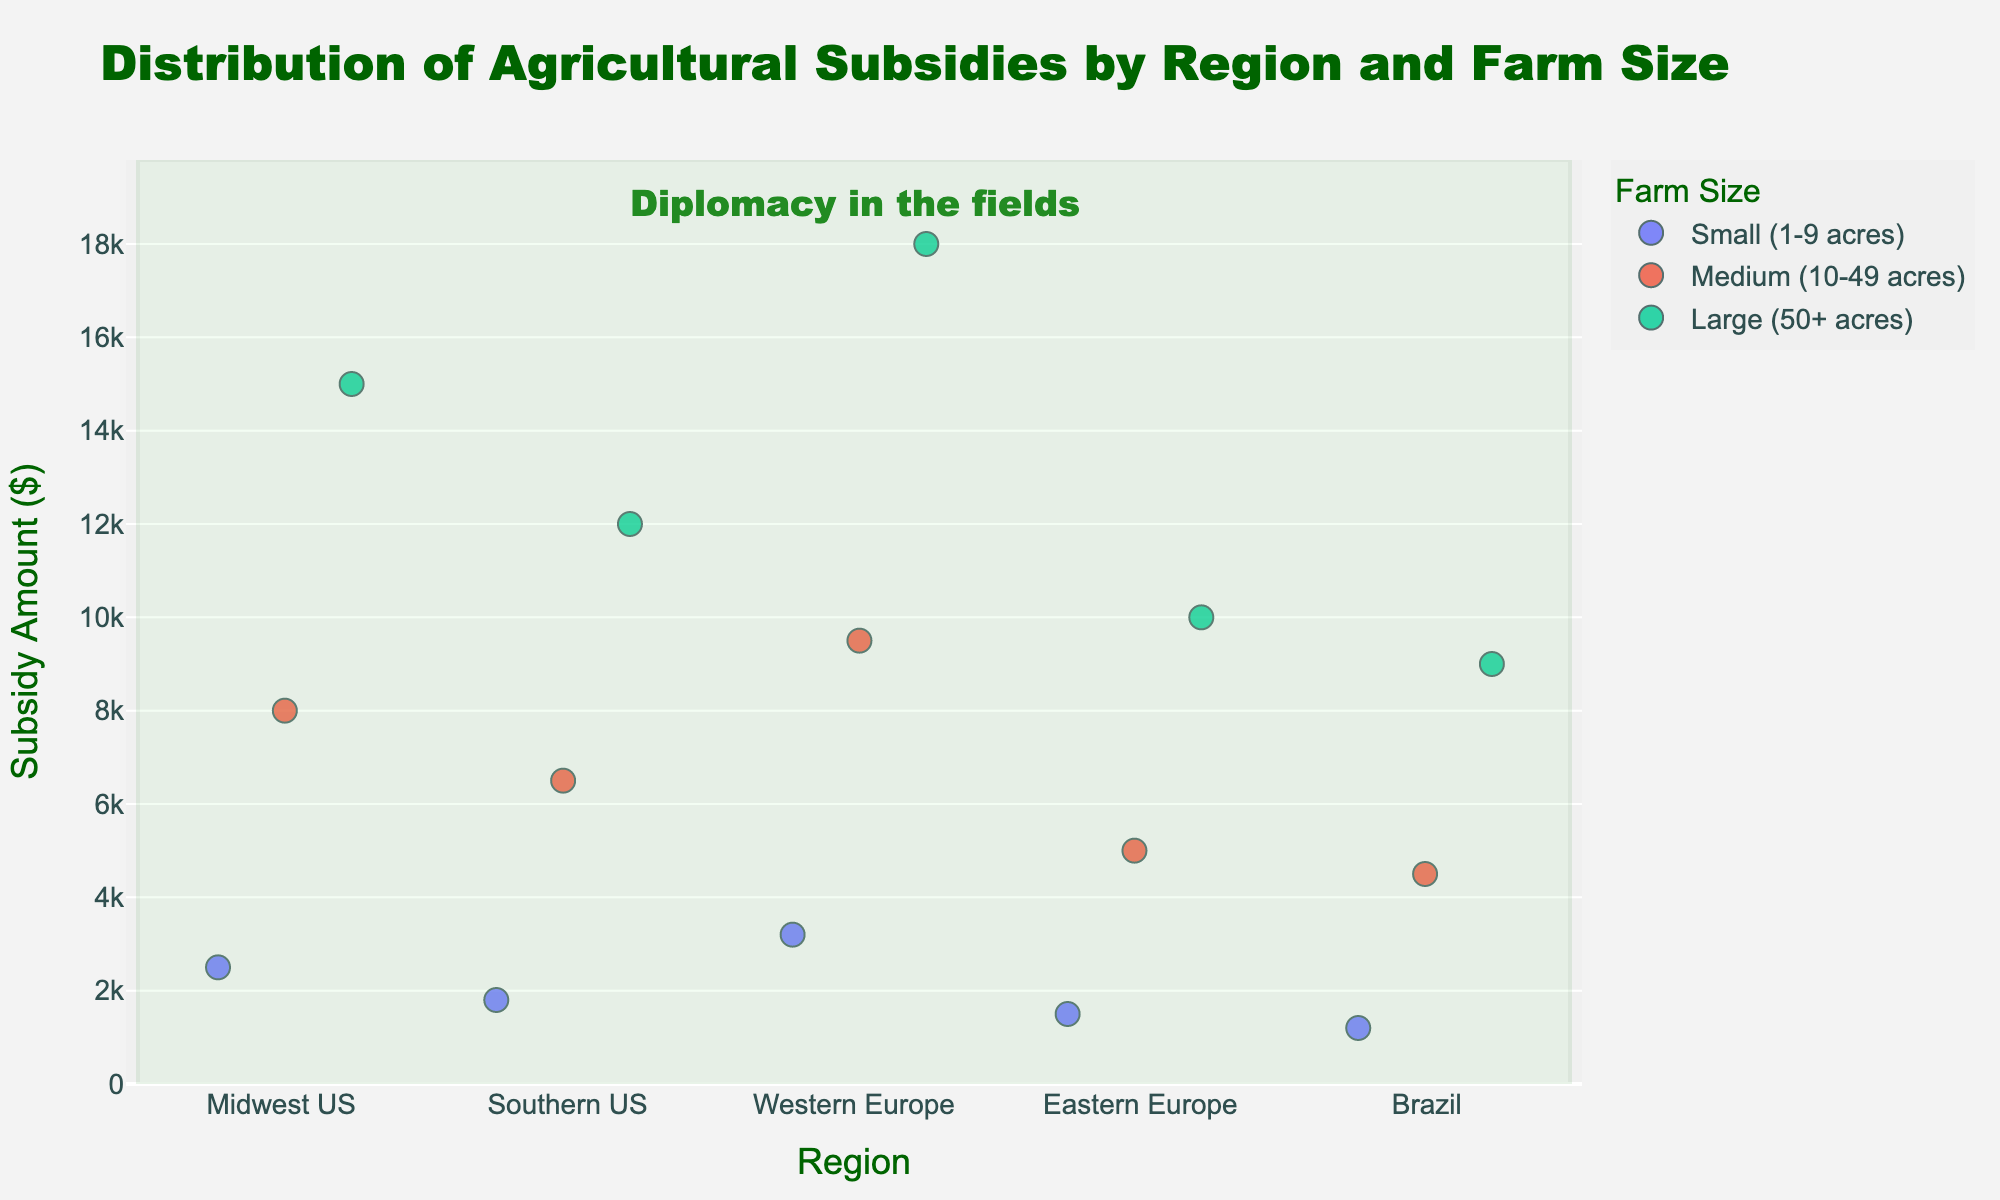What is the title of the strip plot? The title is usually mentioned at the top of the plot. The title displayed is "Distribution of Agricultural Subsidies by Region and Farm Size".
Answer: Distribution of Agricultural Subsidies by Region and Farm Size Which region received the highest subsidy amount for large farms? From the strip plot, the highest point for large farms can be identified. In this case, the "Large (50+ acres)" farms in "Western Europe" received the highest subsidy amount of 18000.
Answer: Western Europe What is the range of subsidy amounts in the Eastern Europe region? By looking at the vertical spread of dots in the Eastern Europe region: the minimum is 1500 (Small (1-9 acres)) and the maximum is 10000 (Large (50+ acres)). So, the range is 10000 - 1500.
Answer: 8500 Which farm size category receives the least subsidy in the Southern US and what is that amount? Checking the position of the lowest point within the Southern US region on the y-axis, the "Small (1-9 acres)" farm size category in the Southern US receives the least subsidy amount, which is 1800.
Answer: Small (1-9 acres), 1800 Compare the subsidy amounts for small farms between the Midwest US and Brazil. Which one is higher and by how much? In the Midwest US, the subsidy amount for small farms is 2500, while in Brazil, it is 1200. The difference is 2500 - 1200 = 1300.
Answer: Midwest US by 1300 What is the average subsidy amount for medium farms across all regions? The subsidy amounts for medium farms across all regions are: 8000 (Midwest US), 6500 (Southern US), 9500 (Western Europe), 5000 (Eastern Europe), and 4500 (Brazil). Sum = 8000 + 6500 + 9500 + 5000 + 4500 = 33500. Average = 33500 / 5.
Answer: 6700 Are the subsidy amounts for medium farms in the Midwest US and Western Europe greater than those in Eastern Europe and Brazil? Checking each value, Midwest US (8000) and Western Europe (9500) amounts can be observed respectively, exceeding Eastern Europe (5000) and Brazil (4500).
Answer: Yes Which region has the smallest gap between the subsidy amounts for small and large farms? Observe each region: 
Midwest US: 15000 - 2500 = 12500
Southern US: 12000 - 1800 = 10200
Western Europe: 18000 - 3200 = 14800
Eastern Europe: 10000 - 1500 = 8500
Brazil: 9000 - 1200 = 7800 
The smallest gap is in Brazil.
Answer: Brazil How does the subsidy amount trend with farm size in Western Europe? Observing the Western Europe region, subsidy amounts for progressively larger farms are: Small (3200), Medium (9500), and Large (18000). The trend is increasing with farm size.
Answer: Increasing Is there a region where the subsidy amounts for medium farms are higher than those for large farms? Check all regions' subsidy amounts: For large farms are always higher than for medium farms in all regions.
Answer: No 